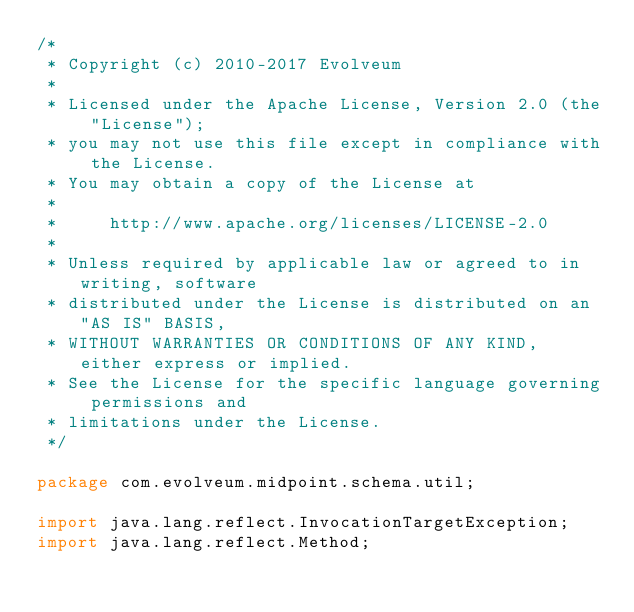Convert code to text. <code><loc_0><loc_0><loc_500><loc_500><_Java_>/*
 * Copyright (c) 2010-2017 Evolveum
 *
 * Licensed under the Apache License, Version 2.0 (the "License");
 * you may not use this file except in compliance with the License.
 * You may obtain a copy of the License at
 *
 *     http://www.apache.org/licenses/LICENSE-2.0
 *
 * Unless required by applicable law or agreed to in writing, software
 * distributed under the License is distributed on an "AS IS" BASIS,
 * WITHOUT WARRANTIES OR CONDITIONS OF ANY KIND, either express or implied.
 * See the License for the specific language governing permissions and
 * limitations under the License.
 */

package com.evolveum.midpoint.schema.util;

import java.lang.reflect.InvocationTargetException;
import java.lang.reflect.Method;</code> 